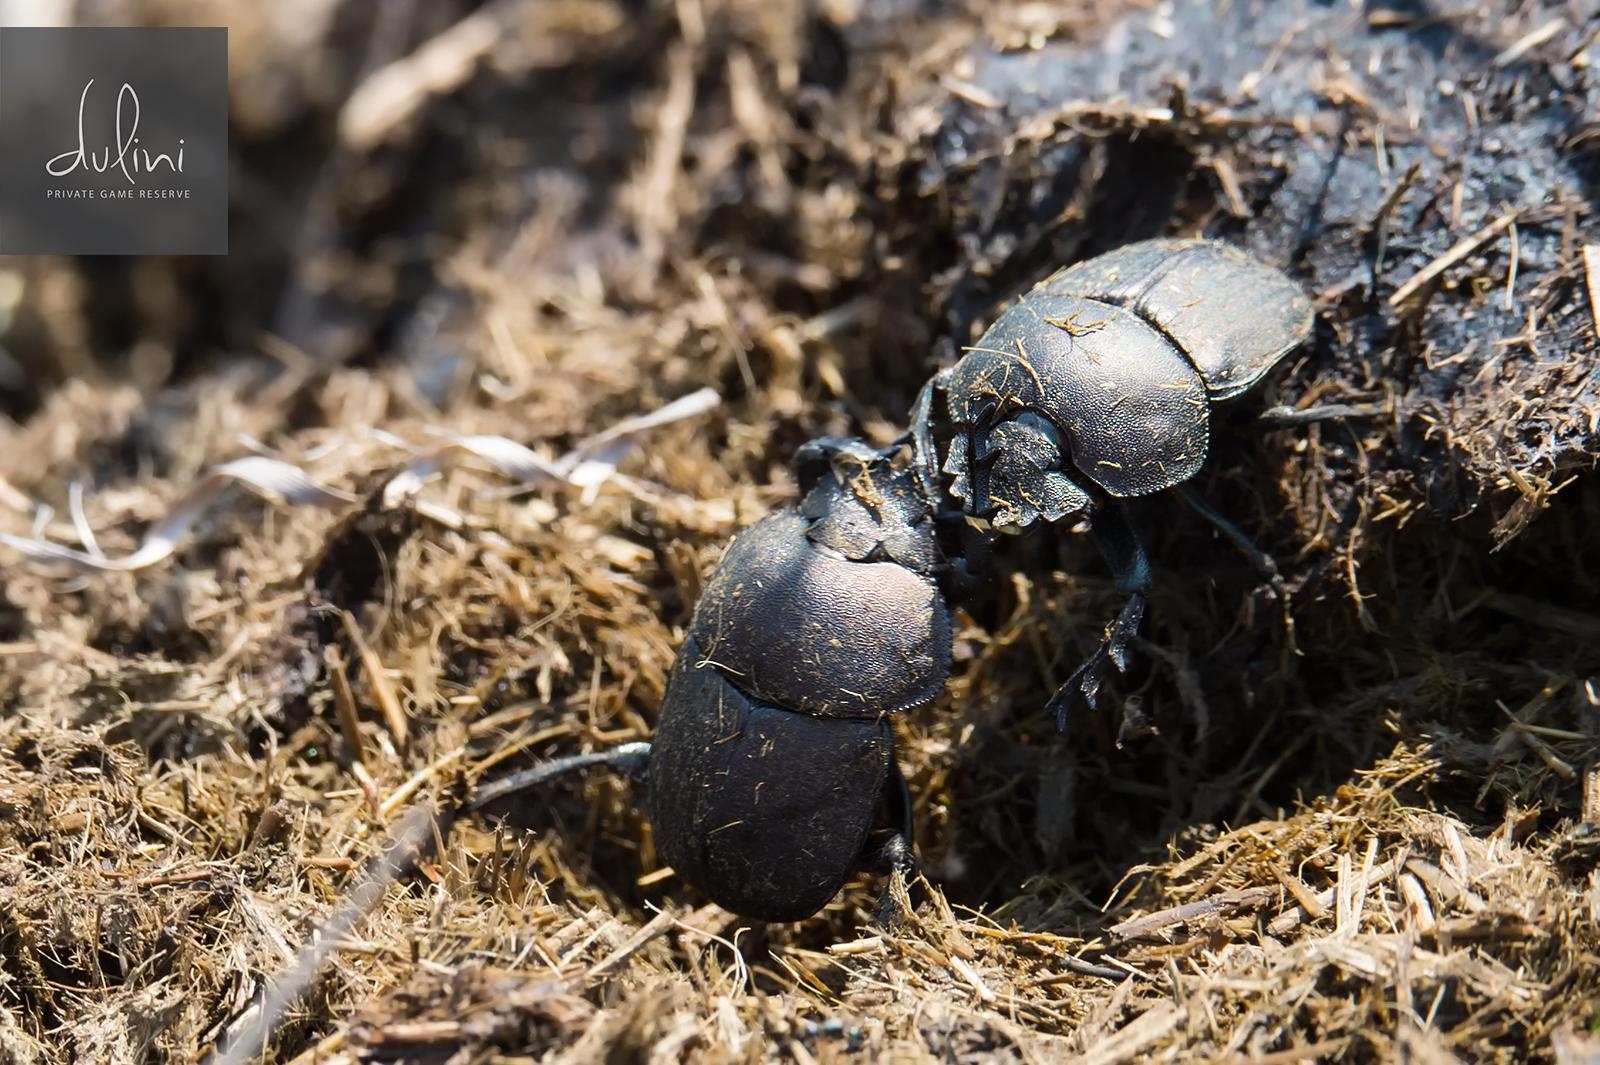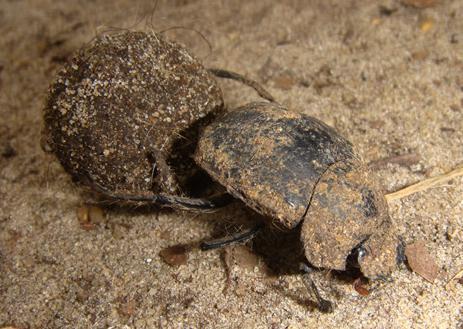The first image is the image on the left, the second image is the image on the right. For the images shown, is this caption "There is at most three beetles." true? Answer yes or no. Yes. The first image is the image on the left, the second image is the image on the right. Examine the images to the left and right. Is the description "In the image on the left, there is no more than one beetle present, industriously building the dung ball." accurate? Answer yes or no. No. 